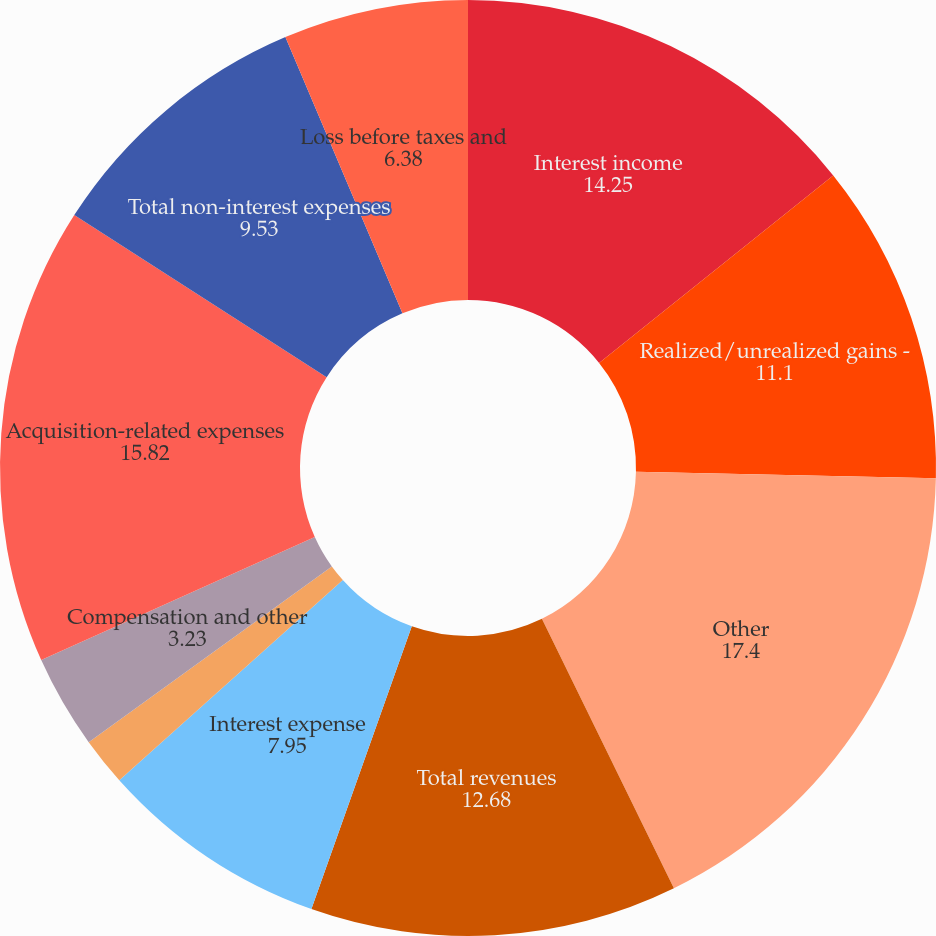Convert chart to OTSL. <chart><loc_0><loc_0><loc_500><loc_500><pie_chart><fcel>Interest income<fcel>Realized/unrealized gains -<fcel>Other<fcel>Total revenues<fcel>Interest expense<fcel>Net revenues<fcel>Compensation and other<fcel>Acquisition-related expenses<fcel>Total non-interest expenses<fcel>Loss before taxes and<nl><fcel>14.25%<fcel>11.1%<fcel>17.4%<fcel>12.68%<fcel>7.95%<fcel>1.66%<fcel>3.23%<fcel>15.82%<fcel>9.53%<fcel>6.38%<nl></chart> 